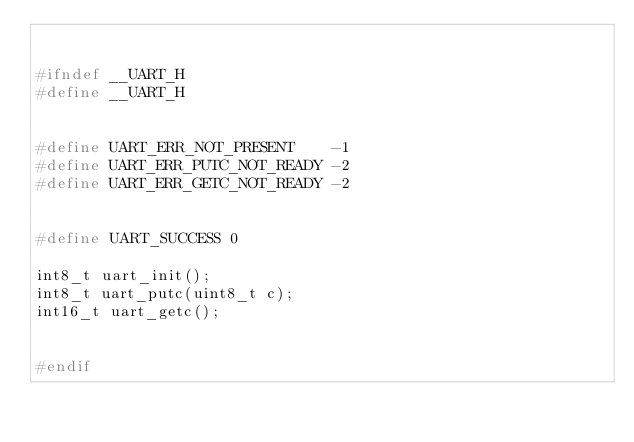<code> <loc_0><loc_0><loc_500><loc_500><_C_>

#ifndef __UART_H
#define __UART_H


#define UART_ERR_NOT_PRESENT    -1
#define UART_ERR_PUTC_NOT_READY -2
#define UART_ERR_GETC_NOT_READY -2


#define UART_SUCCESS 0

int8_t uart_init();
int8_t uart_putc(uint8_t c);
int16_t uart_getc();


#endif
</code> 